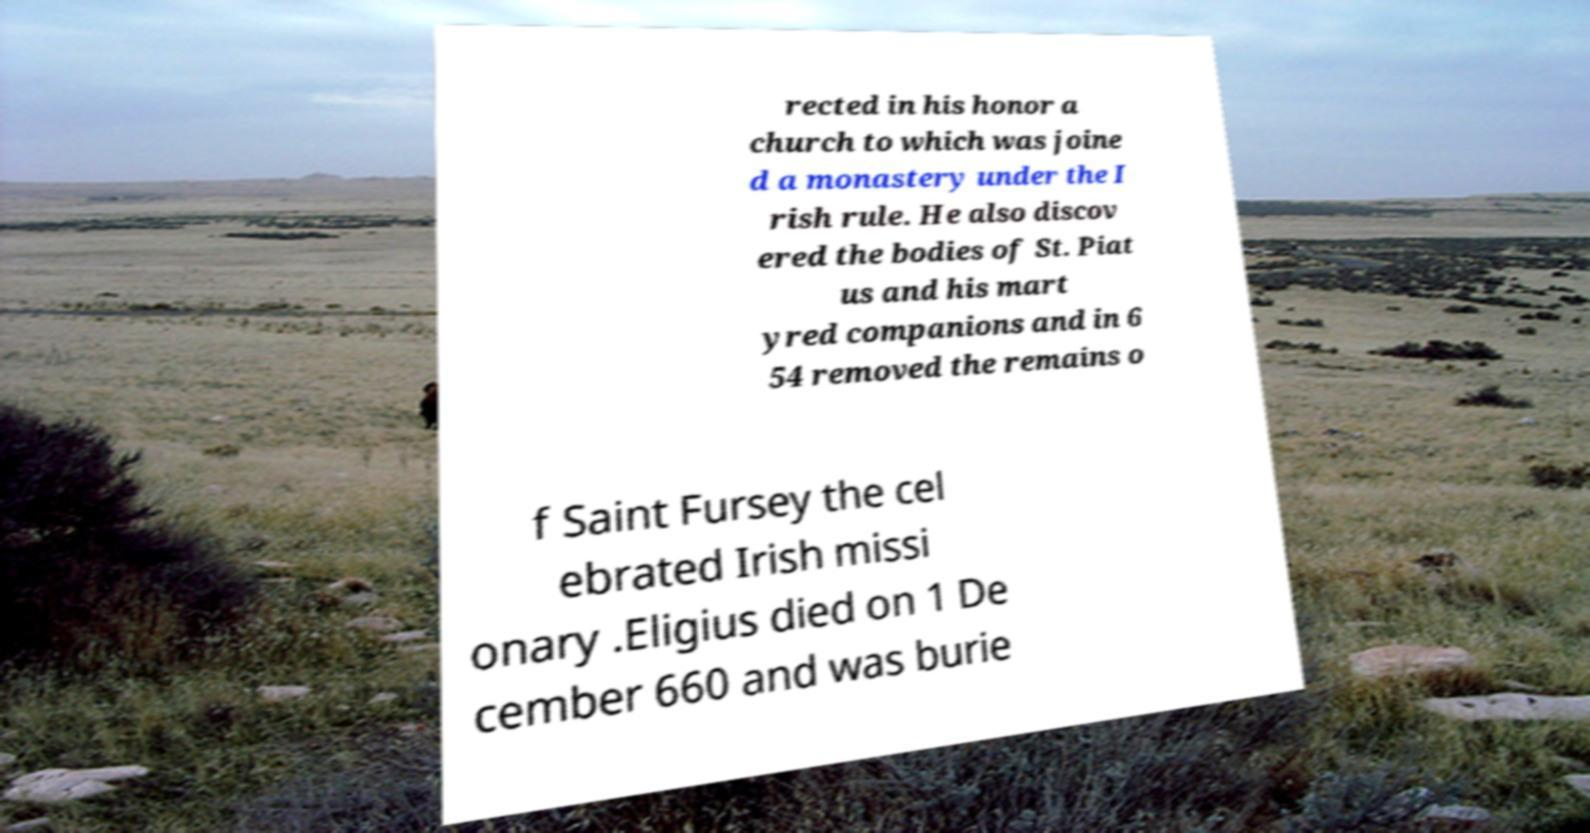I need the written content from this picture converted into text. Can you do that? rected in his honor a church to which was joine d a monastery under the I rish rule. He also discov ered the bodies of St. Piat us and his mart yred companions and in 6 54 removed the remains o f Saint Fursey the cel ebrated Irish missi onary .Eligius died on 1 De cember 660 and was burie 